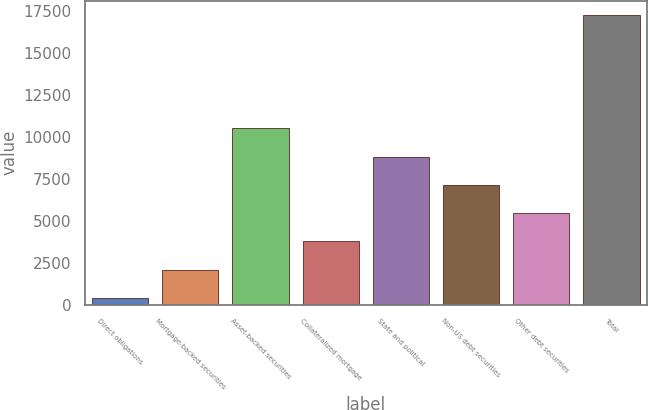Convert chart to OTSL. <chart><loc_0><loc_0><loc_500><loc_500><bar_chart><fcel>Direct obligations<fcel>Mortgage-backed securities<fcel>Asset-backed securities<fcel>Collateralized mortgage<fcel>State and political<fcel>Non-US debt securities<fcel>Other debt securities<fcel>Total<nl><fcel>398<fcel>2082.6<fcel>10505.6<fcel>3767.2<fcel>8821<fcel>7136.4<fcel>5451.8<fcel>17244<nl></chart> 